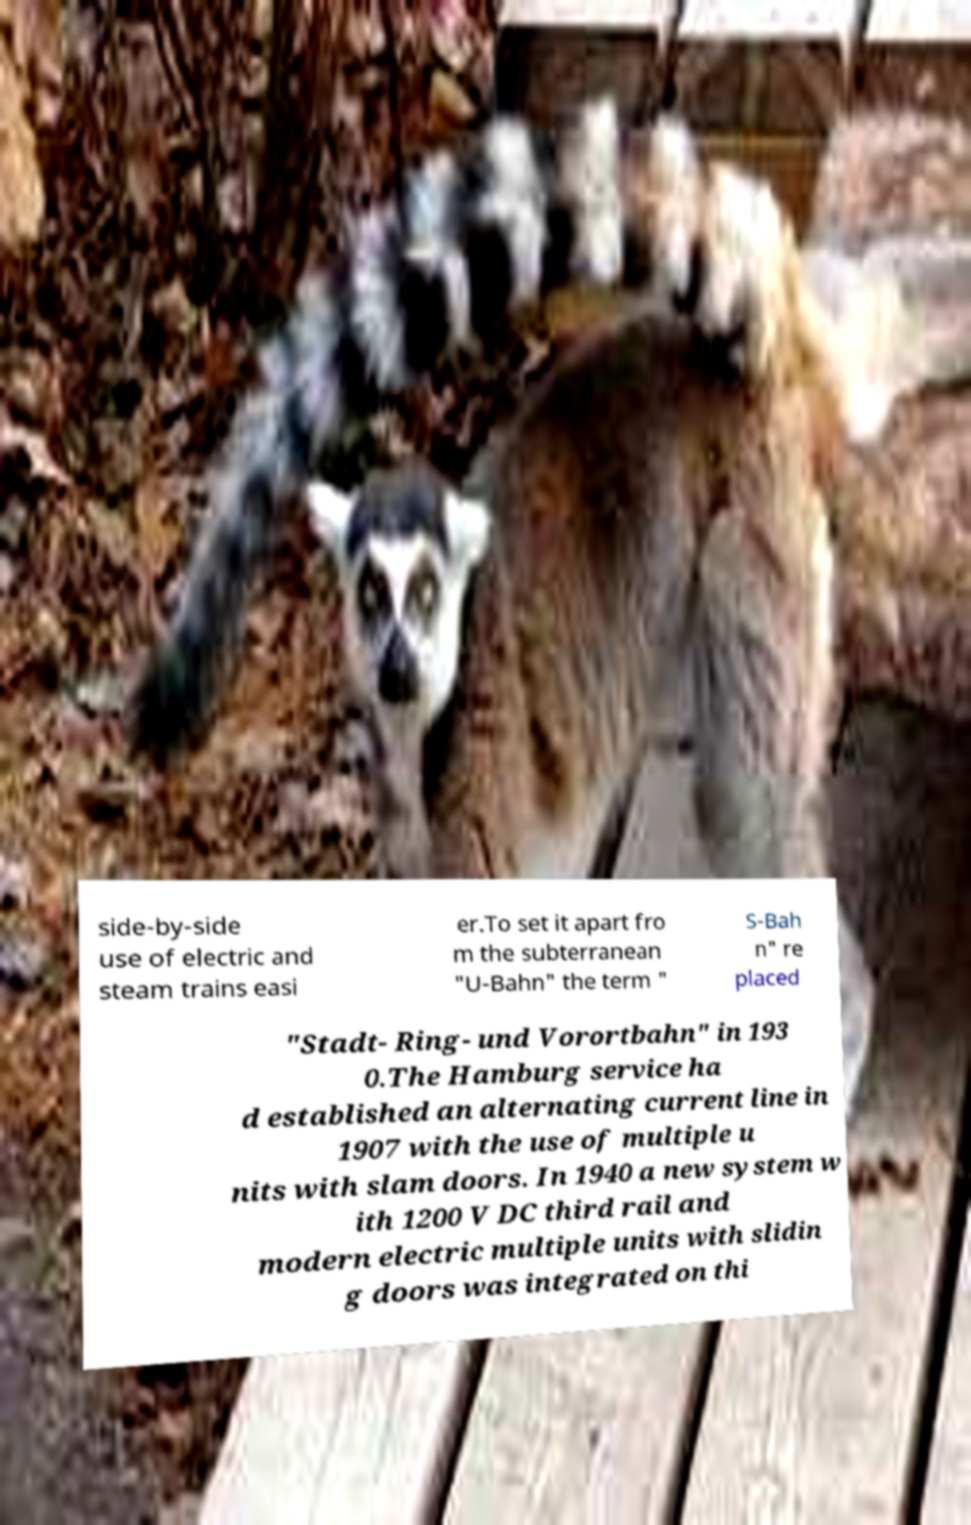Could you assist in decoding the text presented in this image and type it out clearly? side-by-side use of electric and steam trains easi er.To set it apart fro m the subterranean "U-Bahn" the term " S-Bah n" re placed "Stadt- Ring- und Vorortbahn" in 193 0.The Hamburg service ha d established an alternating current line in 1907 with the use of multiple u nits with slam doors. In 1940 a new system w ith 1200 V DC third rail and modern electric multiple units with slidin g doors was integrated on thi 